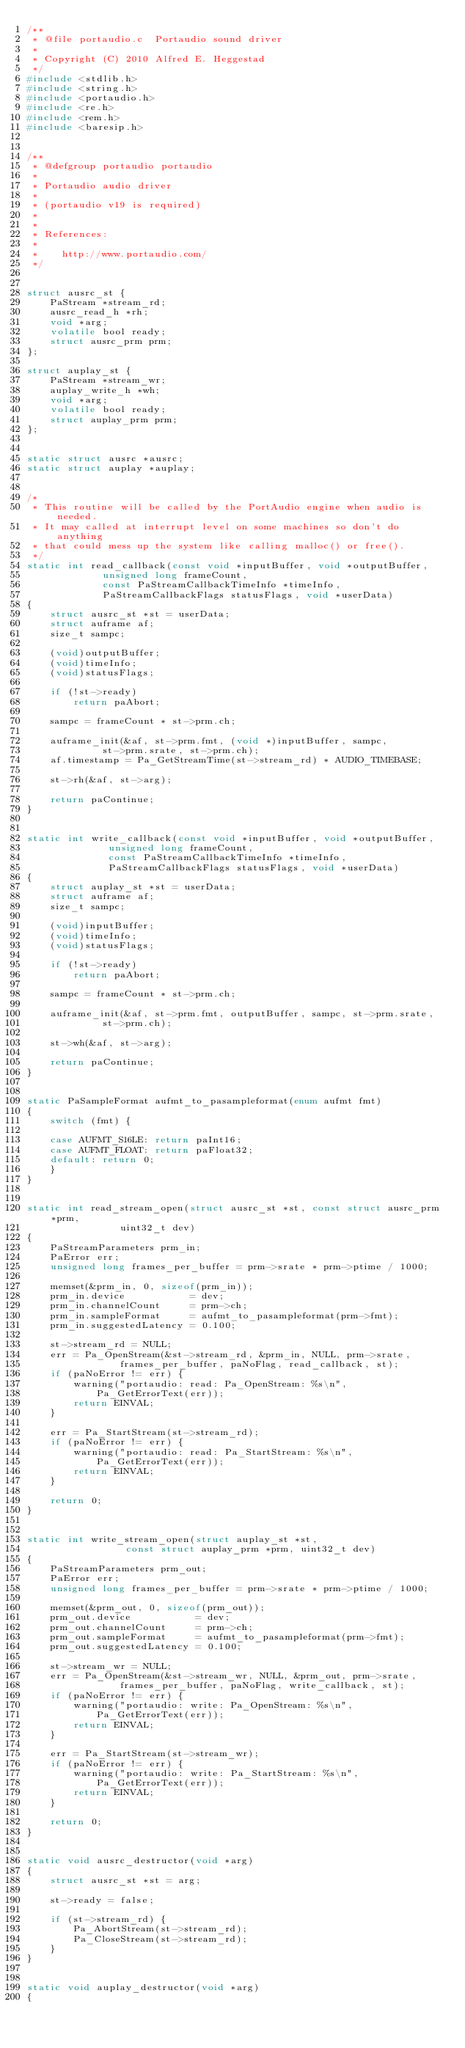Convert code to text. <code><loc_0><loc_0><loc_500><loc_500><_C_>/**
 * @file portaudio.c  Portaudio sound driver
 *
 * Copyright (C) 2010 Alfred E. Heggestad
 */
#include <stdlib.h>
#include <string.h>
#include <portaudio.h>
#include <re.h>
#include <rem.h>
#include <baresip.h>


/**
 * @defgroup portaudio portaudio
 *
 * Portaudio audio driver
 *
 * (portaudio v19 is required)
 *
 *
 * References:
 *
 *    http://www.portaudio.com/
 */


struct ausrc_st {
	PaStream *stream_rd;
	ausrc_read_h *rh;
	void *arg;
	volatile bool ready;
	struct ausrc_prm prm;
};

struct auplay_st {
	PaStream *stream_wr;
	auplay_write_h *wh;
	void *arg;
	volatile bool ready;
	struct auplay_prm prm;
};


static struct ausrc *ausrc;
static struct auplay *auplay;


/*
 * This routine will be called by the PortAudio engine when audio is needed.
 * It may called at interrupt level on some machines so don't do anything
 * that could mess up the system like calling malloc() or free().
 */
static int read_callback(const void *inputBuffer, void *outputBuffer,
			 unsigned long frameCount,
			 const PaStreamCallbackTimeInfo *timeInfo,
			 PaStreamCallbackFlags statusFlags, void *userData)
{
	struct ausrc_st *st = userData;
	struct auframe af;
	size_t sampc;

	(void)outputBuffer;
	(void)timeInfo;
	(void)statusFlags;

	if (!st->ready)
		return paAbort;

	sampc = frameCount * st->prm.ch;

	auframe_init(&af, st->prm.fmt, (void *)inputBuffer, sampc,
		     st->prm.srate, st->prm.ch);
	af.timestamp = Pa_GetStreamTime(st->stream_rd) * AUDIO_TIMEBASE;

	st->rh(&af, st->arg);

	return paContinue;
}


static int write_callback(const void *inputBuffer, void *outputBuffer,
			  unsigned long frameCount,
			  const PaStreamCallbackTimeInfo *timeInfo,
			  PaStreamCallbackFlags statusFlags, void *userData)
{
	struct auplay_st *st = userData;
	struct auframe af;
	size_t sampc;

	(void)inputBuffer;
	(void)timeInfo;
	(void)statusFlags;

	if (!st->ready)
		return paAbort;

	sampc = frameCount * st->prm.ch;

	auframe_init(&af, st->prm.fmt, outputBuffer, sampc, st->prm.srate,
		     st->prm.ch);

	st->wh(&af, st->arg);

	return paContinue;
}


static PaSampleFormat aufmt_to_pasampleformat(enum aufmt fmt)
{
	switch (fmt) {

	case AUFMT_S16LE: return paInt16;
	case AUFMT_FLOAT: return paFloat32;
	default: return 0;
	}
}


static int read_stream_open(struct ausrc_st *st, const struct ausrc_prm *prm,
			    uint32_t dev)
{
	PaStreamParameters prm_in;
	PaError err;
	unsigned long frames_per_buffer = prm->srate * prm->ptime / 1000;

	memset(&prm_in, 0, sizeof(prm_in));
	prm_in.device           = dev;
	prm_in.channelCount     = prm->ch;
	prm_in.sampleFormat     = aufmt_to_pasampleformat(prm->fmt);
	prm_in.suggestedLatency = 0.100;

	st->stream_rd = NULL;
	err = Pa_OpenStream(&st->stream_rd, &prm_in, NULL, prm->srate,
			    frames_per_buffer, paNoFlag, read_callback, st);
	if (paNoError != err) {
		warning("portaudio: read: Pa_OpenStream: %s\n",
			Pa_GetErrorText(err));
		return EINVAL;
	}

	err = Pa_StartStream(st->stream_rd);
	if (paNoError != err) {
		warning("portaudio: read: Pa_StartStream: %s\n",
			Pa_GetErrorText(err));
		return EINVAL;
	}

	return 0;
}


static int write_stream_open(struct auplay_st *st,
			     const struct auplay_prm *prm, uint32_t dev)
{
	PaStreamParameters prm_out;
	PaError err;
	unsigned long frames_per_buffer = prm->srate * prm->ptime / 1000;

	memset(&prm_out, 0, sizeof(prm_out));
	prm_out.device           = dev;
	prm_out.channelCount     = prm->ch;
	prm_out.sampleFormat     = aufmt_to_pasampleformat(prm->fmt);
	prm_out.suggestedLatency = 0.100;

	st->stream_wr = NULL;
	err = Pa_OpenStream(&st->stream_wr, NULL, &prm_out, prm->srate,
			    frames_per_buffer, paNoFlag, write_callback, st);
	if (paNoError != err) {
		warning("portaudio: write: Pa_OpenStream: %s\n",
			Pa_GetErrorText(err));
		return EINVAL;
	}

	err = Pa_StartStream(st->stream_wr);
	if (paNoError != err) {
		warning("portaudio: write: Pa_StartStream: %s\n",
			Pa_GetErrorText(err));
		return EINVAL;
	}

	return 0;
}


static void ausrc_destructor(void *arg)
{
	struct ausrc_st *st = arg;

	st->ready = false;

	if (st->stream_rd) {
		Pa_AbortStream(st->stream_rd);
		Pa_CloseStream(st->stream_rd);
	}
}


static void auplay_destructor(void *arg)
{</code> 